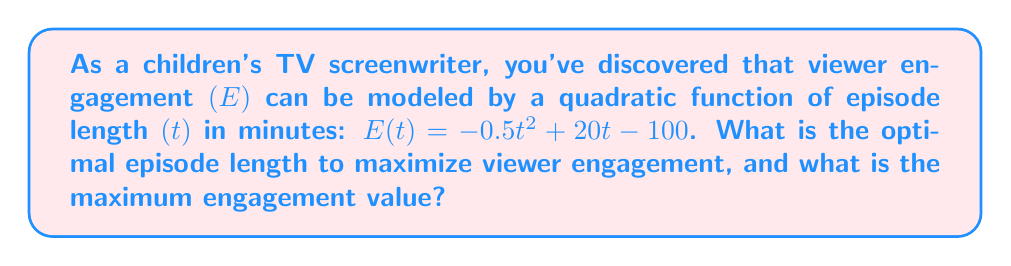Can you solve this math problem? To solve this problem, we'll follow these steps:

1) The function $E(t) = -0.5t^2 + 20t - 100$ is a quadratic function in the form $f(x) = ax^2 + bx + c$, where:
   $a = -0.5$
   $b = 20$
   $c = -100$

2) For a quadratic function, the vertex represents the maximum or minimum point. Since $a$ is negative, this parabola opens downward, so the vertex will be the maximum point.

3) To find the t-coordinate of the vertex, we use the formula: $t = -\frac{b}{2a}$

   $$t = -\frac{20}{2(-0.5)} = -\frac{20}{-1} = 20$$

4) This means the optimal episode length is 20 minutes.

5) To find the maximum engagement value, we substitute $t = 20$ into the original function:

   $$\begin{align}
   E(20) &= -0.5(20)^2 + 20(20) - 100 \\
         &= -0.5(400) + 400 - 100 \\
         &= -200 + 400 - 100 \\
         &= 100
   \end{align}$$

Therefore, the maximum engagement value is 100.
Answer: The optimal episode length is 20 minutes, and the maximum engagement value is 100. 